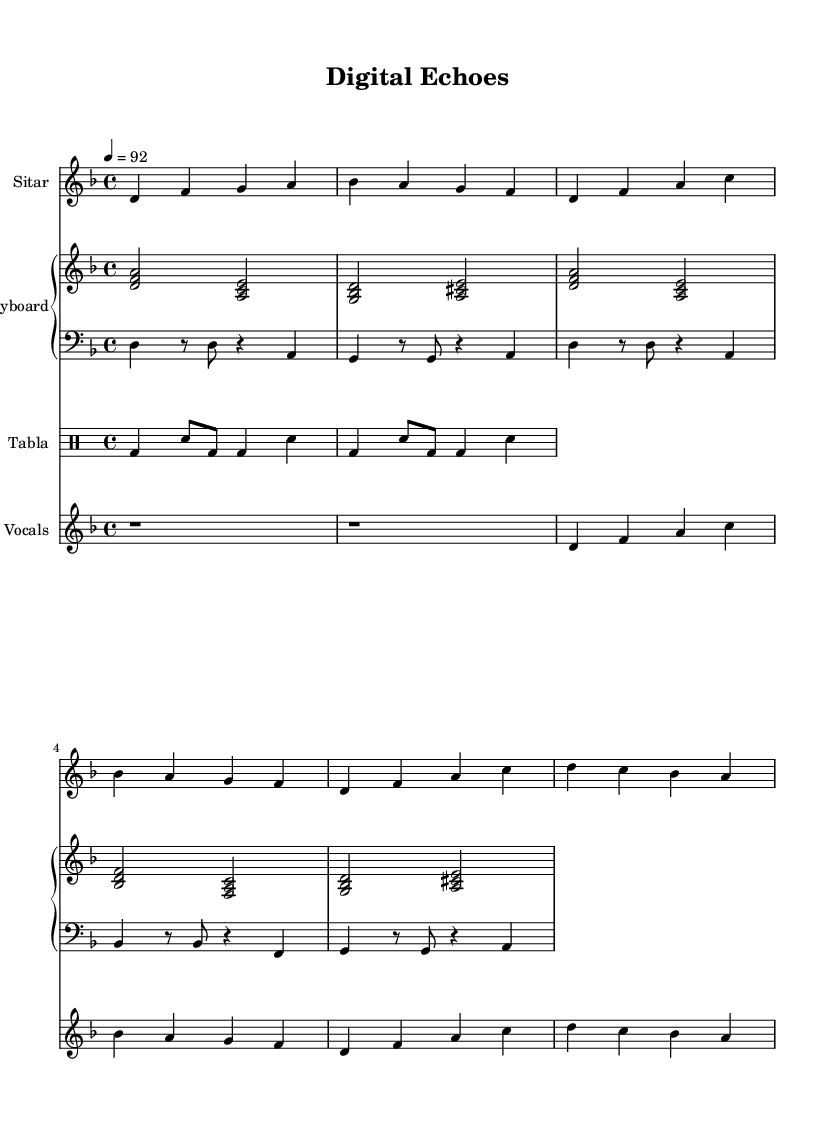What is the key signature of this music? The key signature is indicated at the beginning of the score. It shows two flat symbols, which indicates the key of D minor.
Answer: D minor What is the time signature of this piece? The time signature is found at the beginning of the score, where it shows a “4/4”, indicating that there are four beats in each measure and the quarter note gets one beat.
Answer: 4/4 What is the tempo of the piece? The tempo is indicated at the beginning as “4 = 92”, meaning that there are 92 beats per minute with quarter notes.
Answer: 92 How many measures are present in the sitar part? Counting the vertical lines that separate the measures in the sitar staff shows that there are 6 measures.
Answer: 6 Which instrument is playing a rhythmic role similar to a bass drum? The tabla part, using the "bd" notation, adds a bass drum-like rhythmic element; it is present in the drummode section.
Answer: Tabla What is the highest note played by the vocal part? The highest note is found in the vocal staff when looking at the relative pitch; the highest note is a C, which is the highest note in the sequence played.
Answer: C What instrument part includes chords? The keyboard part includes chords, as indicated by the use of stacked note symbols (for example, <d f a> represents a chord).
Answer: Keyboard 